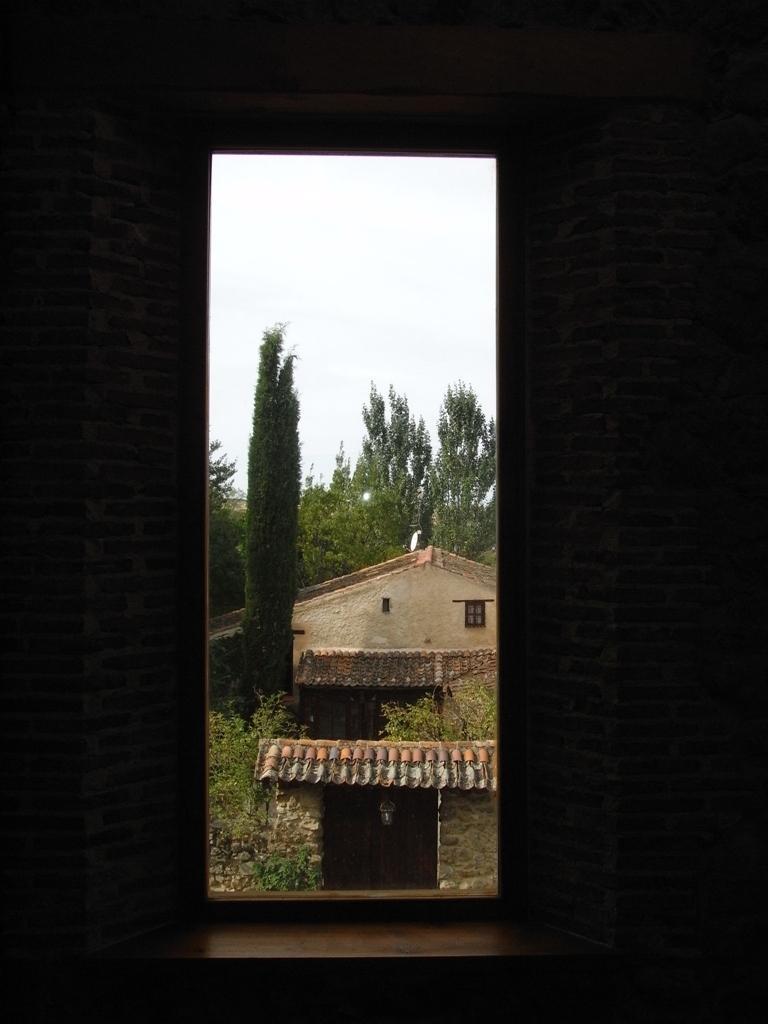Please provide a concise description of this image. On the right and left side of the image I can see the wall. In the background there is a house and trees and on the top I can see the sky. 